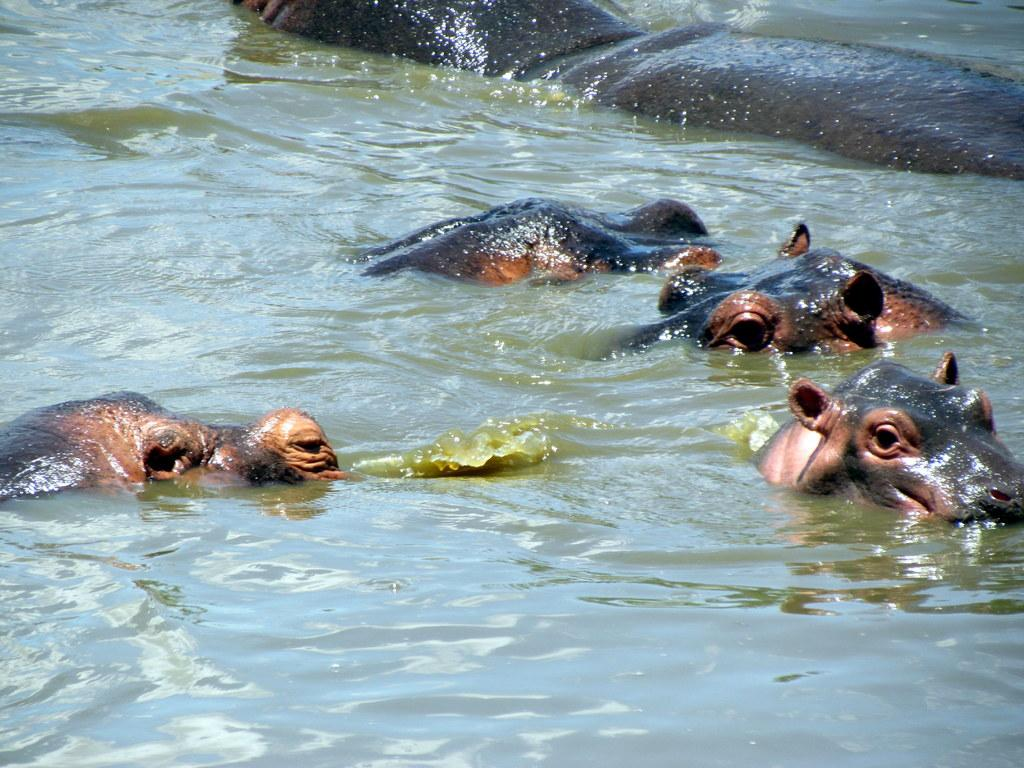What animals are present in the image? There are hippopotamuses in the image. What are the hippopotamuses doing in the image? The hippopotamuses are swimming in the water. What color are the hippopotamuses in the image? The hippopotamuses are in brown color. Can you see any potatoes in the image? There are no potatoes present in the image. What type of bell can be heard ringing in the image? There is no bell present in the image, and therefore no sound can be heard. 